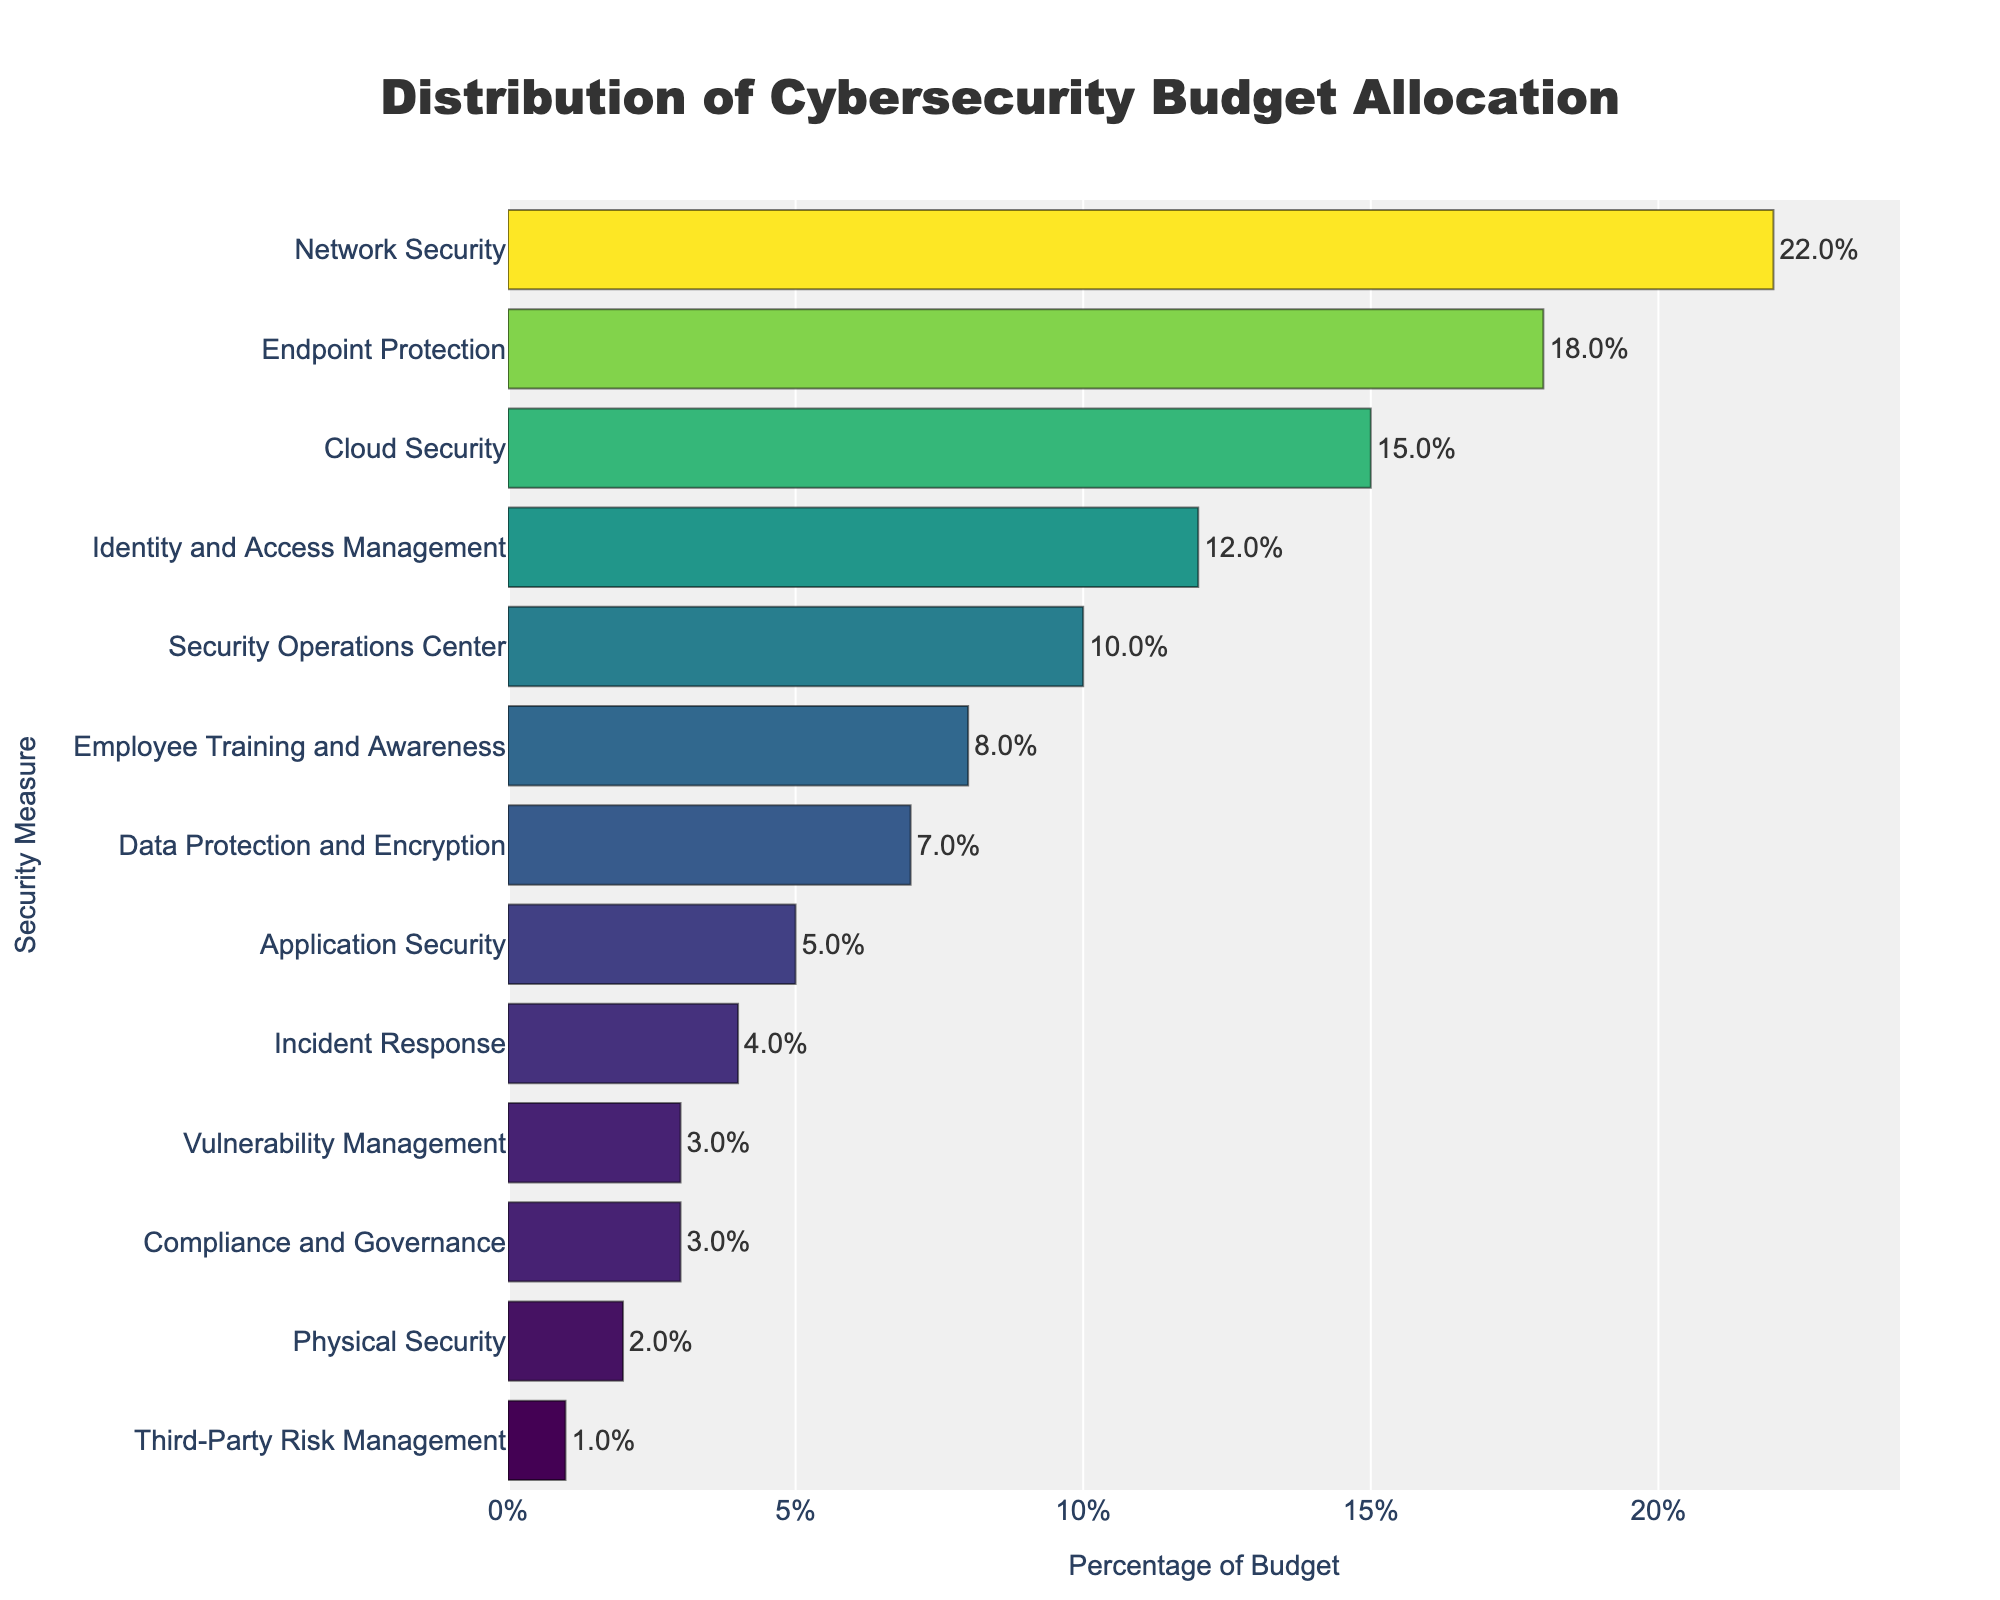What percentage of the budget is allocated to Network Security and Identity and Access Management combined? Network Security is allocated 22% and Identity and Access Management is allocated 12%. Adding them together gives 22% + 12% = 34%.
Answer: 34% Which security measure has the lowest budget allocation and what is its percentage? The measure with the lowest allocation is Third-Party Risk Management, with 1%.
Answer: Third-Party Risk Management, 1% Is the budget allocation for Cloud Security higher or lower than that for Endpoint Protection? By how much? Cloud Security has a 15% allocation and Endpoint Protection has 18%. The difference is 18% - 15% = 3%, so the allocation for Cloud Security is lower by 3%.
Answer: Lower by 3% What is the total percentage of the budget allocated to Security Operations Center and Incident Response? Security Operations Center is allocated 10% and Incident Response is allocated 4%. Adding these gives 10% + 4% = 14%.
Answer: 14% Which two security measures have the closest budget allocations and what are their values? Incident Response and Vulnerability Management have the closest allocations of 4% and 3%, respectively. The difference between them is 1%.
Answer: Incident Response (4%) and Vulnerability Management (3%) How does the budget allocation for Employee Training and Awareness compare to that for Application Security? Employee Training and Awareness has an 8% allocation while Application Security has 5%. This means Employee Training and Awareness has a higher allocation by 8% - 5% = 3%.
Answer: Higher by 3% What percentage of the budget is dedicated to physical and data protection measures combined (Physical Security, Data Protection and Encryption)? Physical Security is allocated 2% and Data Protection and Encryption is allocated 7%. Adding them together gives 2% + 7% = 9%.
Answer: 9% Looking at the colors, which security measure appears to have the darkest color and what is its percentage? The bar with the darkest color seems to be Third-Party Risk Management, which has the lowest budget allocation of 1%.
Answer: Third-Party Risk Management, 1% What is the average budget allocation for all security measures listed? To find the average, sum all allocations: 22% + 18% + 15% + 12% + 10% + 8% + 7% + 5% + 4% + 3% + 3% + 2% + 1% = 110%. There are 13 categories, so the average is 110% / 13 ≈ 8.46%.
Answer: 8.46% Which category has a budget allocation just under 10%? Employee Training and Awareness has an allocation of 8%, which is just under 10%.
Answer: Employee Training and Awareness 